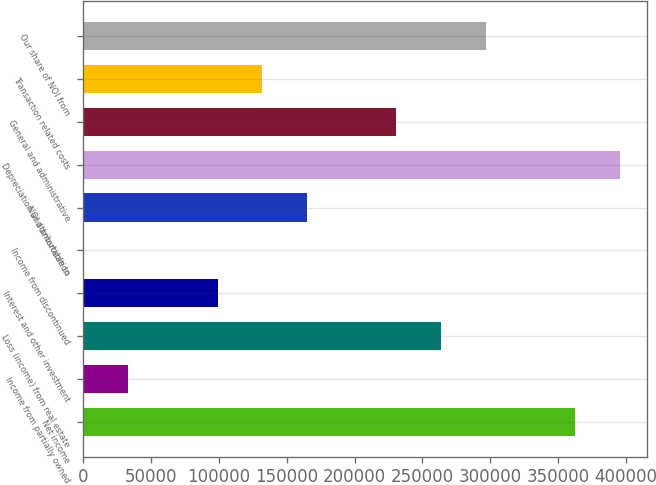<chart> <loc_0><loc_0><loc_500><loc_500><bar_chart><fcel>Net income<fcel>Income from partially owned<fcel>Loss (income) from real estate<fcel>Interest and other investment<fcel>Income from discontinued<fcel>NOI attributable to<fcel>Depreciation and amortization<fcel>General and administrative<fcel>Transaction related costs<fcel>Our share of NOI from<nl><fcel>362458<fcel>33184.4<fcel>263676<fcel>99039.2<fcel>257<fcel>164894<fcel>395386<fcel>230749<fcel>131967<fcel>296604<nl></chart> 